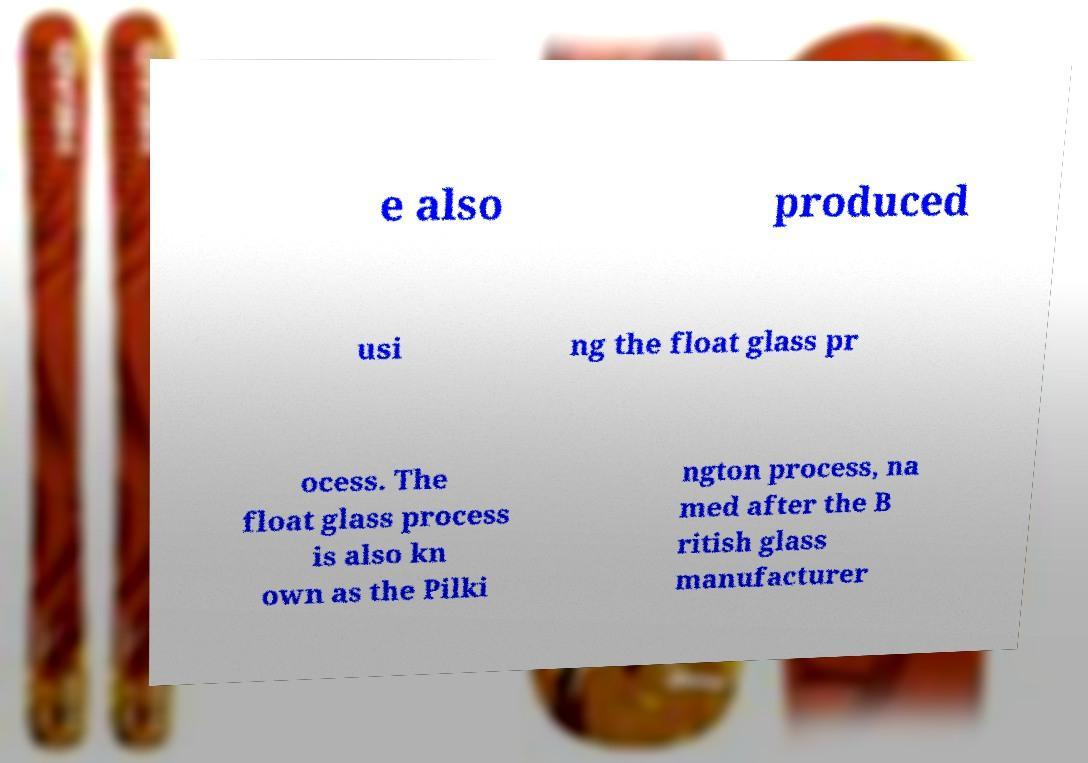Could you extract and type out the text from this image? e also produced usi ng the float glass pr ocess. The float glass process is also kn own as the Pilki ngton process, na med after the B ritish glass manufacturer 